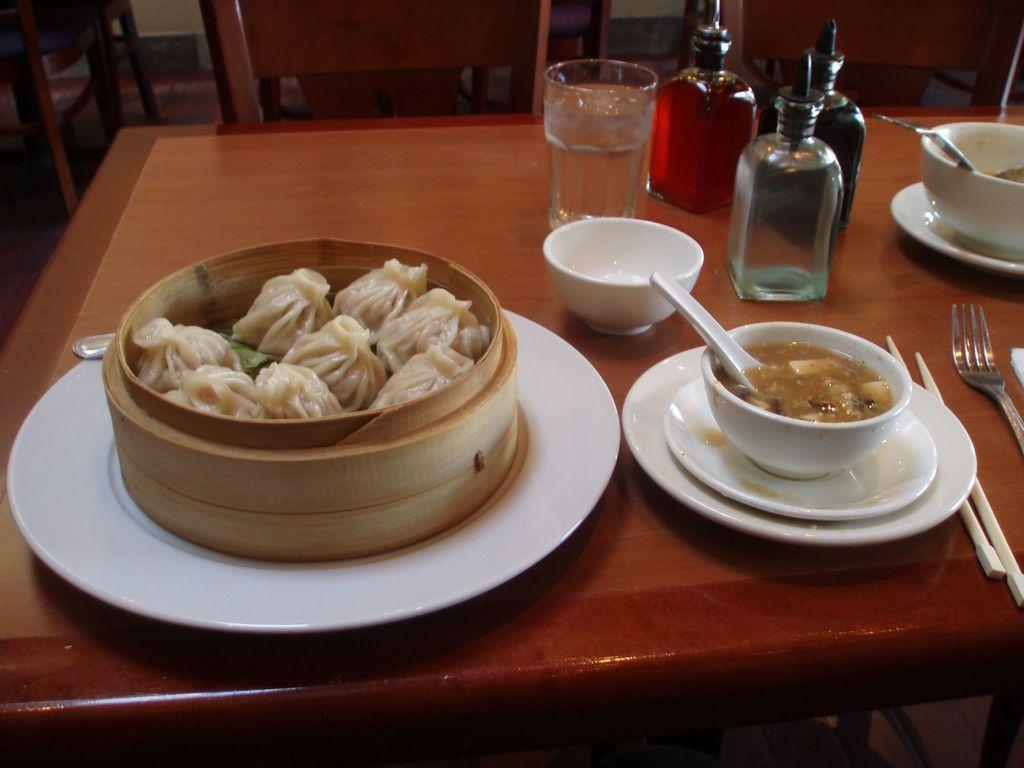Can you describe this image briefly? In this picture we can see a table. On the table there are bowls, plates, bottles, and fork. This is some food. And there is a chair. 